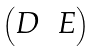<formula> <loc_0><loc_0><loc_500><loc_500>\begin{pmatrix} D & E \\ \end{pmatrix}</formula> 